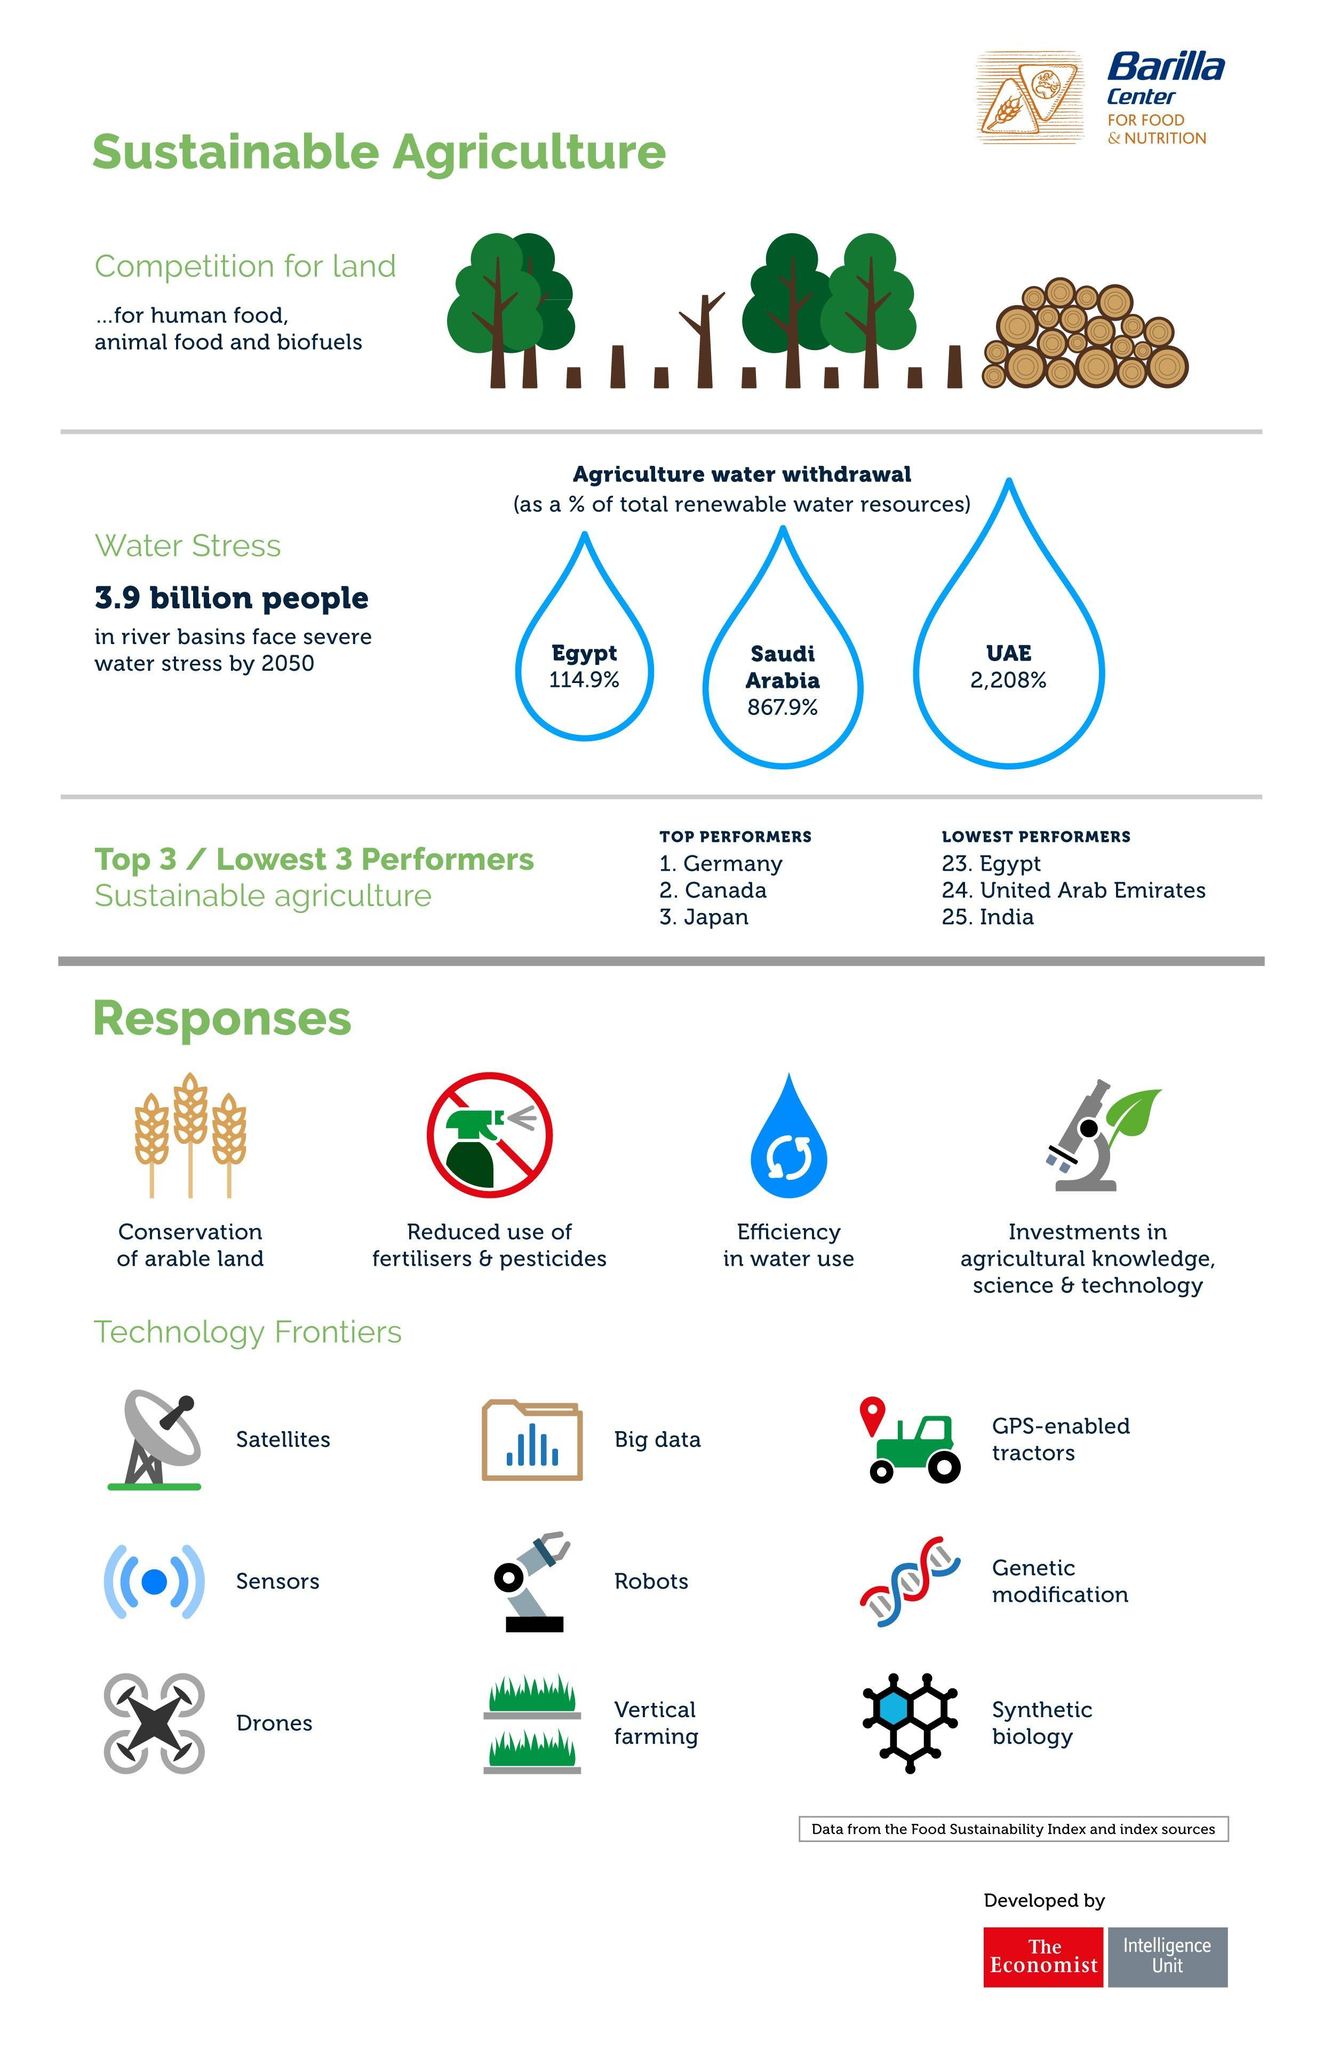India is lower in performance than which country
Answer the question with a short phrase. United Arab Emirates where can robots and big data be used technology frontiers have many methods have been identified in the technology frontier 9 how many types of responses have been identified 4 what is the agriculture water withdrawal for UAE 2,208% 